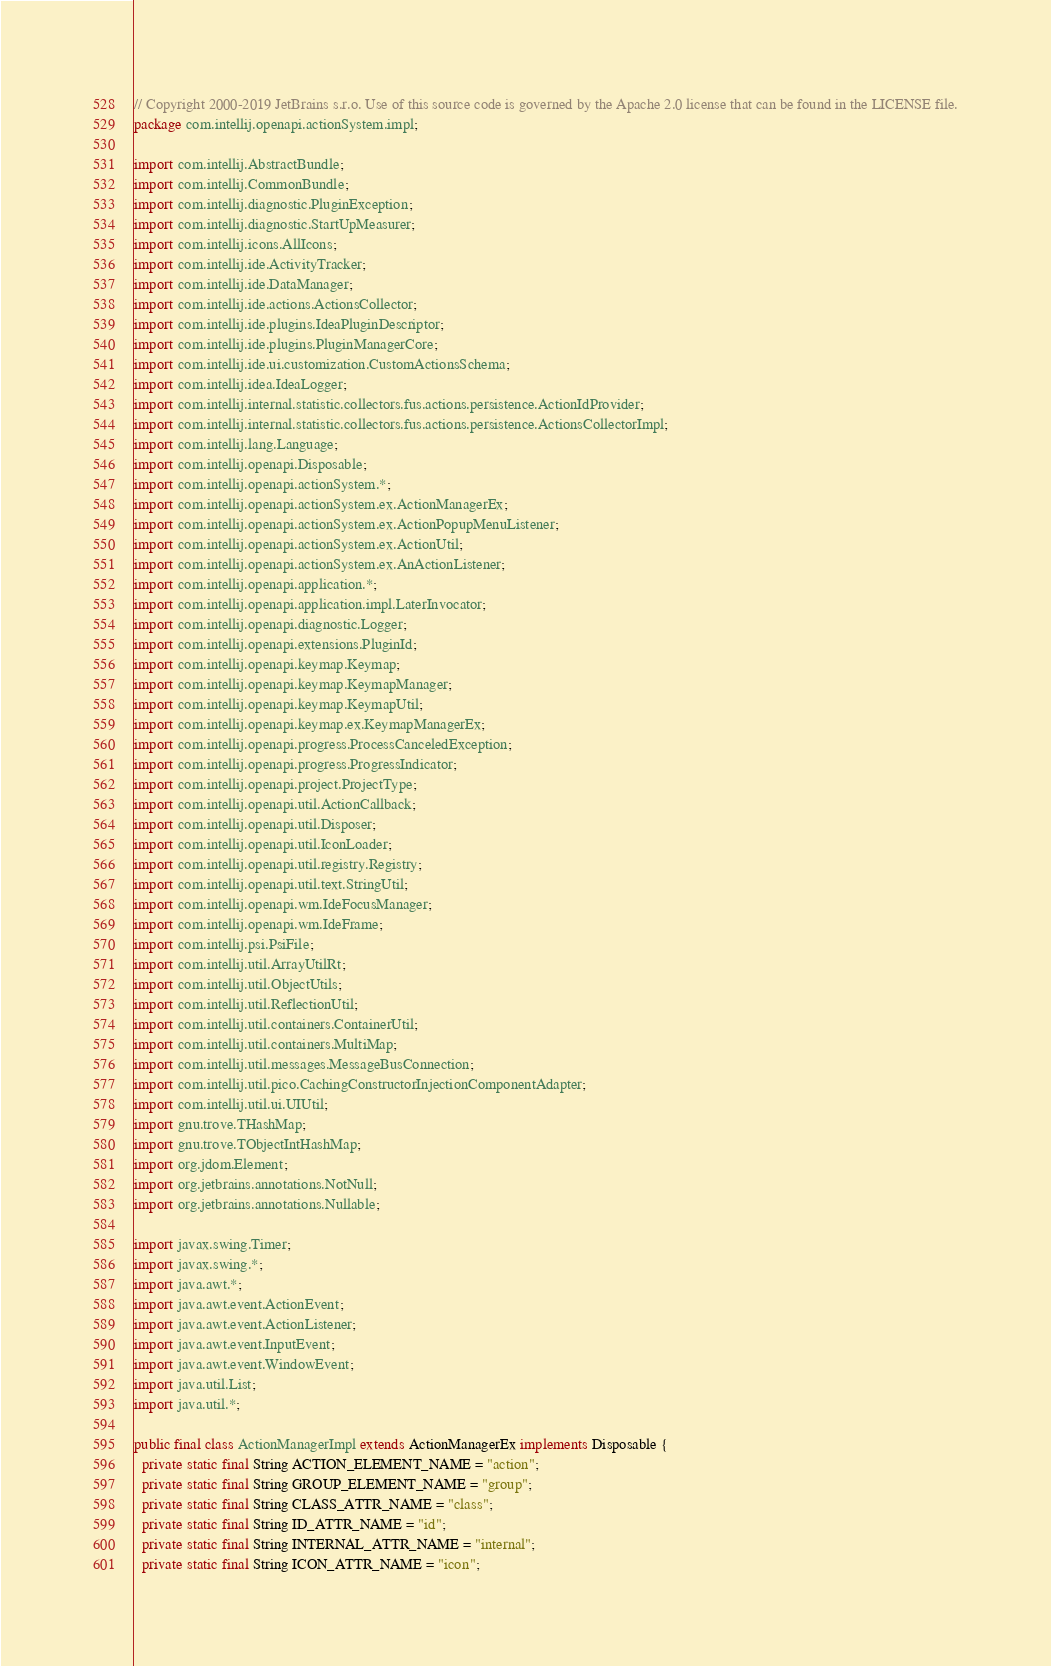Convert code to text. <code><loc_0><loc_0><loc_500><loc_500><_Java_>// Copyright 2000-2019 JetBrains s.r.o. Use of this source code is governed by the Apache 2.0 license that can be found in the LICENSE file.
package com.intellij.openapi.actionSystem.impl;

import com.intellij.AbstractBundle;
import com.intellij.CommonBundle;
import com.intellij.diagnostic.PluginException;
import com.intellij.diagnostic.StartUpMeasurer;
import com.intellij.icons.AllIcons;
import com.intellij.ide.ActivityTracker;
import com.intellij.ide.DataManager;
import com.intellij.ide.actions.ActionsCollector;
import com.intellij.ide.plugins.IdeaPluginDescriptor;
import com.intellij.ide.plugins.PluginManagerCore;
import com.intellij.ide.ui.customization.CustomActionsSchema;
import com.intellij.idea.IdeaLogger;
import com.intellij.internal.statistic.collectors.fus.actions.persistence.ActionIdProvider;
import com.intellij.internal.statistic.collectors.fus.actions.persistence.ActionsCollectorImpl;
import com.intellij.lang.Language;
import com.intellij.openapi.Disposable;
import com.intellij.openapi.actionSystem.*;
import com.intellij.openapi.actionSystem.ex.ActionManagerEx;
import com.intellij.openapi.actionSystem.ex.ActionPopupMenuListener;
import com.intellij.openapi.actionSystem.ex.ActionUtil;
import com.intellij.openapi.actionSystem.ex.AnActionListener;
import com.intellij.openapi.application.*;
import com.intellij.openapi.application.impl.LaterInvocator;
import com.intellij.openapi.diagnostic.Logger;
import com.intellij.openapi.extensions.PluginId;
import com.intellij.openapi.keymap.Keymap;
import com.intellij.openapi.keymap.KeymapManager;
import com.intellij.openapi.keymap.KeymapUtil;
import com.intellij.openapi.keymap.ex.KeymapManagerEx;
import com.intellij.openapi.progress.ProcessCanceledException;
import com.intellij.openapi.progress.ProgressIndicator;
import com.intellij.openapi.project.ProjectType;
import com.intellij.openapi.util.ActionCallback;
import com.intellij.openapi.util.Disposer;
import com.intellij.openapi.util.IconLoader;
import com.intellij.openapi.util.registry.Registry;
import com.intellij.openapi.util.text.StringUtil;
import com.intellij.openapi.wm.IdeFocusManager;
import com.intellij.openapi.wm.IdeFrame;
import com.intellij.psi.PsiFile;
import com.intellij.util.ArrayUtilRt;
import com.intellij.util.ObjectUtils;
import com.intellij.util.ReflectionUtil;
import com.intellij.util.containers.ContainerUtil;
import com.intellij.util.containers.MultiMap;
import com.intellij.util.messages.MessageBusConnection;
import com.intellij.util.pico.CachingConstructorInjectionComponentAdapter;
import com.intellij.util.ui.UIUtil;
import gnu.trove.THashMap;
import gnu.trove.TObjectIntHashMap;
import org.jdom.Element;
import org.jetbrains.annotations.NotNull;
import org.jetbrains.annotations.Nullable;

import javax.swing.Timer;
import javax.swing.*;
import java.awt.*;
import java.awt.event.ActionEvent;
import java.awt.event.ActionListener;
import java.awt.event.InputEvent;
import java.awt.event.WindowEvent;
import java.util.List;
import java.util.*;

public final class ActionManagerImpl extends ActionManagerEx implements Disposable {
  private static final String ACTION_ELEMENT_NAME = "action";
  private static final String GROUP_ELEMENT_NAME = "group";
  private static final String CLASS_ATTR_NAME = "class";
  private static final String ID_ATTR_NAME = "id";
  private static final String INTERNAL_ATTR_NAME = "internal";
  private static final String ICON_ATTR_NAME = "icon";</code> 